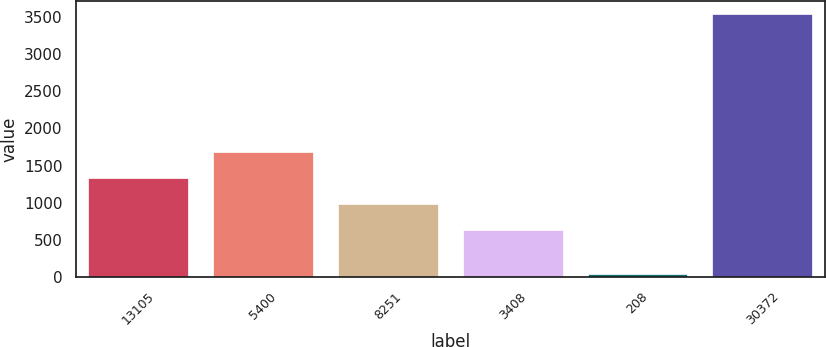Convert chart. <chart><loc_0><loc_0><loc_500><loc_500><bar_chart><fcel>13105<fcel>5400<fcel>8251<fcel>3408<fcel>208<fcel>30372<nl><fcel>1327<fcel>1676.5<fcel>977.5<fcel>628<fcel>44<fcel>3539<nl></chart> 